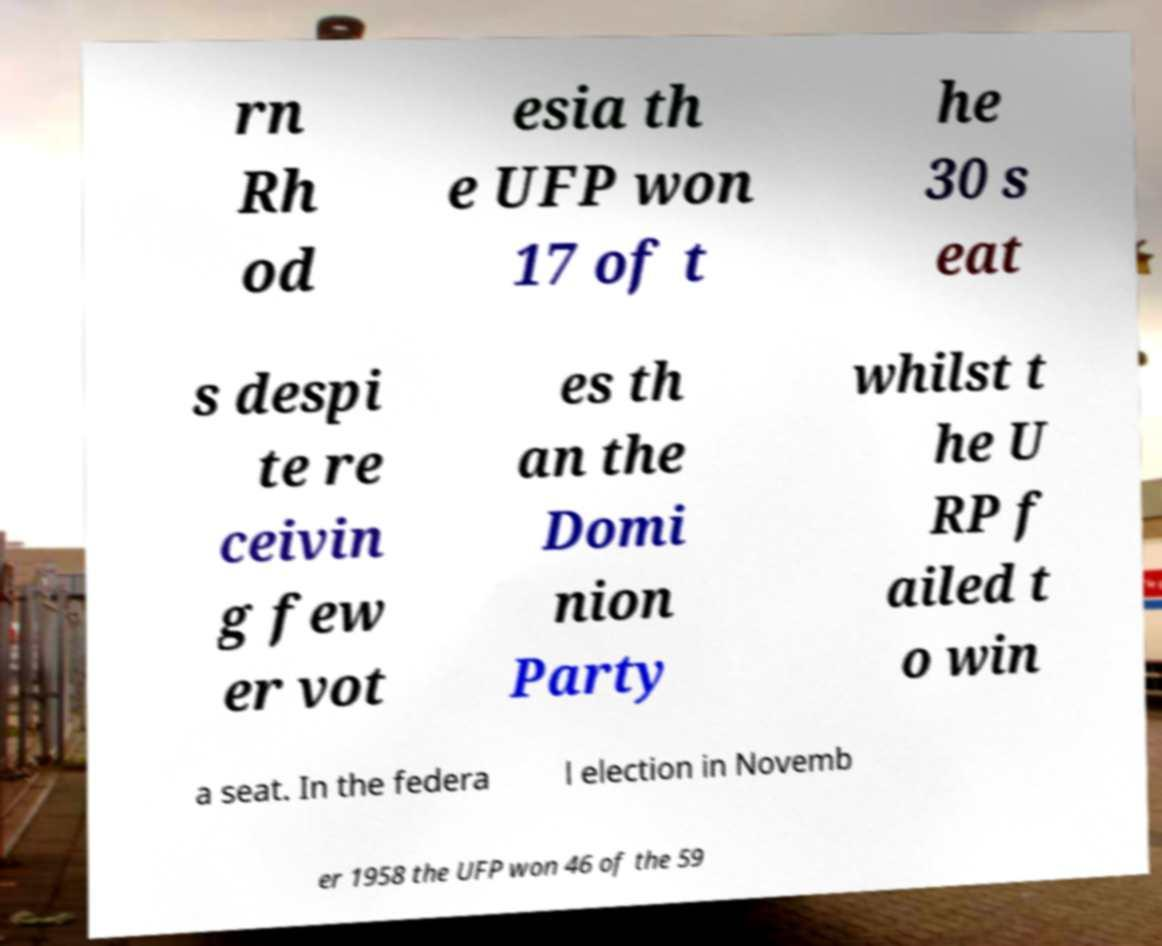Could you assist in decoding the text presented in this image and type it out clearly? rn Rh od esia th e UFP won 17 of t he 30 s eat s despi te re ceivin g few er vot es th an the Domi nion Party whilst t he U RP f ailed t o win a seat. In the federa l election in Novemb er 1958 the UFP won 46 of the 59 